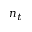<formula> <loc_0><loc_0><loc_500><loc_500>n _ { t }</formula> 